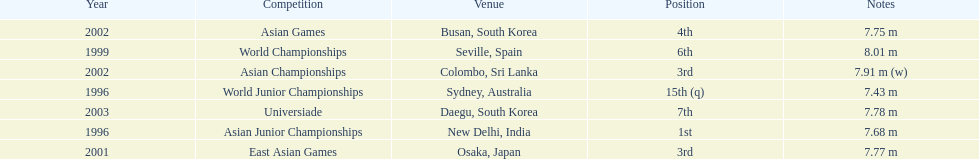How many times did his jump surpass 7.70 m? 5. 